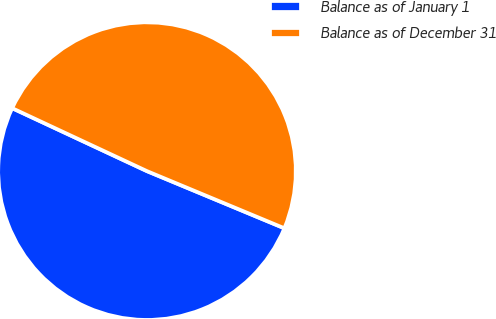Convert chart. <chart><loc_0><loc_0><loc_500><loc_500><pie_chart><fcel>Balance as of January 1<fcel>Balance as of December 31<nl><fcel>50.68%<fcel>49.32%<nl></chart> 